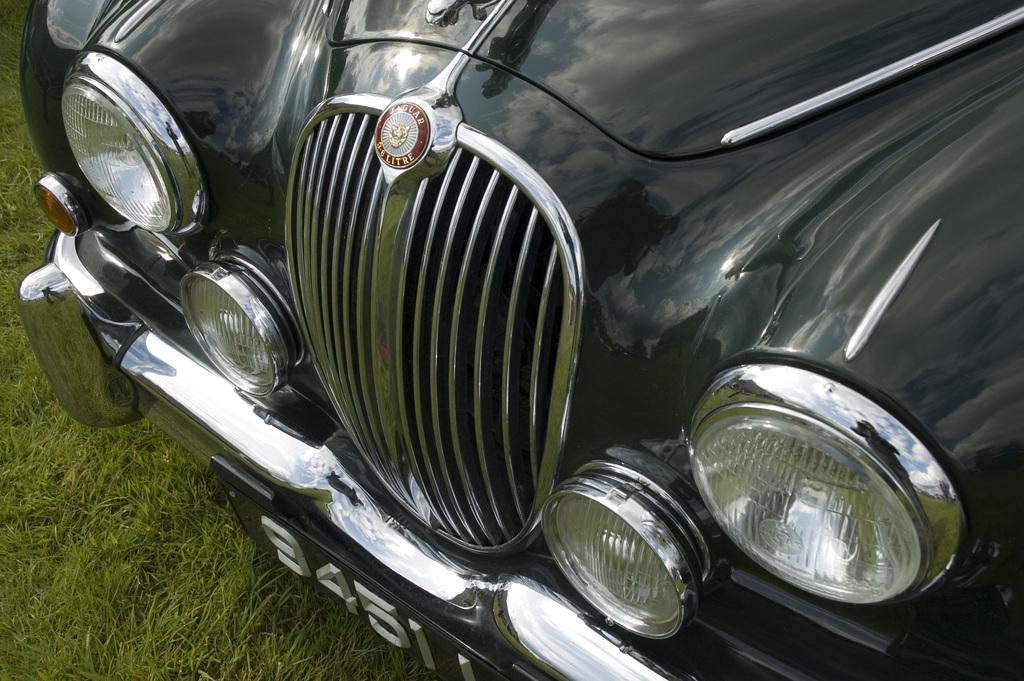What part of a car is visible in the image? The front part of a car is visible in the image. What are the headlights used for on the car? The headlights are used for illuminating the road when driving in low light conditions. What protects the car's front end from damage in case of a collision? The car has a bumper to protect its front end from damage in case of a collision. What is the unique identifier for the car in the image? There is a number plate on the car, which serves as its unique identifier. What type of boats can be seen sailing in the background of the image? There are no boats visible in the image; it only shows the front part of a car. 